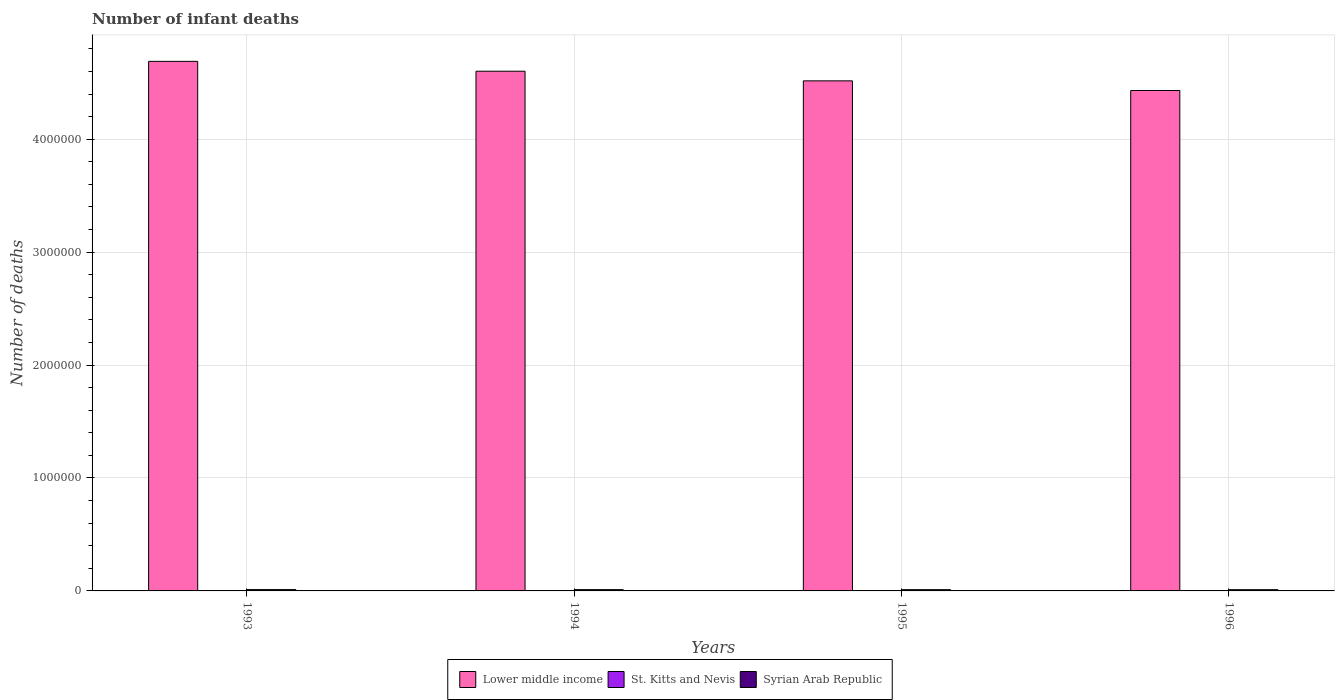How many different coloured bars are there?
Your response must be concise. 3. Are the number of bars per tick equal to the number of legend labels?
Provide a short and direct response. Yes. How many bars are there on the 4th tick from the left?
Provide a short and direct response. 3. What is the label of the 2nd group of bars from the left?
Give a very brief answer. 1994. What is the number of infant deaths in Lower middle income in 1994?
Offer a terse response. 4.60e+06. What is the total number of infant deaths in Syrian Arab Republic in the graph?
Keep it short and to the point. 4.48e+04. What is the difference between the number of infant deaths in St. Kitts and Nevis in 1993 and that in 1994?
Offer a very short reply. 0. What is the difference between the number of infant deaths in Syrian Arab Republic in 1993 and the number of infant deaths in St. Kitts and Nevis in 1995?
Give a very brief answer. 1.17e+04. What is the average number of infant deaths in Syrian Arab Republic per year?
Your answer should be compact. 1.12e+04. In the year 1995, what is the difference between the number of infant deaths in St. Kitts and Nevis and number of infant deaths in Syrian Arab Republic?
Your response must be concise. -1.09e+04. In how many years, is the number of infant deaths in Syrian Arab Republic greater than 200000?
Give a very brief answer. 0. What is the ratio of the number of infant deaths in Lower middle income in 1993 to that in 1996?
Ensure brevity in your answer.  1.06. Is the number of infant deaths in Syrian Arab Republic in 1994 less than that in 1996?
Your answer should be very brief. No. What is the difference between the highest and the second highest number of infant deaths in St. Kitts and Nevis?
Offer a very short reply. 0. What is the difference between the highest and the lowest number of infant deaths in Lower middle income?
Keep it short and to the point. 2.58e+05. What does the 2nd bar from the left in 1996 represents?
Provide a short and direct response. St. Kitts and Nevis. What does the 3rd bar from the right in 1995 represents?
Provide a succinct answer. Lower middle income. Is it the case that in every year, the sum of the number of infant deaths in Syrian Arab Republic and number of infant deaths in St. Kitts and Nevis is greater than the number of infant deaths in Lower middle income?
Offer a very short reply. No. What is the difference between two consecutive major ticks on the Y-axis?
Your response must be concise. 1.00e+06. Does the graph contain any zero values?
Provide a short and direct response. No. Does the graph contain grids?
Keep it short and to the point. Yes. Where does the legend appear in the graph?
Keep it short and to the point. Bottom center. How are the legend labels stacked?
Ensure brevity in your answer.  Horizontal. What is the title of the graph?
Give a very brief answer. Number of infant deaths. Does "Malta" appear as one of the legend labels in the graph?
Your response must be concise. No. What is the label or title of the Y-axis?
Keep it short and to the point. Number of deaths. What is the Number of deaths in Lower middle income in 1993?
Provide a succinct answer. 4.69e+06. What is the Number of deaths in St. Kitts and Nevis in 1993?
Your answer should be very brief. 18. What is the Number of deaths of Syrian Arab Republic in 1993?
Your answer should be compact. 1.17e+04. What is the Number of deaths in Lower middle income in 1994?
Offer a very short reply. 4.60e+06. What is the Number of deaths of St. Kitts and Nevis in 1994?
Offer a very short reply. 18. What is the Number of deaths of Syrian Arab Republic in 1994?
Keep it short and to the point. 1.13e+04. What is the Number of deaths of Lower middle income in 1995?
Give a very brief answer. 4.52e+06. What is the Number of deaths in St. Kitts and Nevis in 1995?
Provide a succinct answer. 17. What is the Number of deaths in Syrian Arab Republic in 1995?
Your answer should be very brief. 1.09e+04. What is the Number of deaths in Lower middle income in 1996?
Offer a very short reply. 4.43e+06. What is the Number of deaths of Syrian Arab Republic in 1996?
Provide a short and direct response. 1.09e+04. Across all years, what is the maximum Number of deaths of Lower middle income?
Give a very brief answer. 4.69e+06. Across all years, what is the maximum Number of deaths of St. Kitts and Nevis?
Make the answer very short. 18. Across all years, what is the maximum Number of deaths of Syrian Arab Republic?
Give a very brief answer. 1.17e+04. Across all years, what is the minimum Number of deaths in Lower middle income?
Your response must be concise. 4.43e+06. Across all years, what is the minimum Number of deaths in St. Kitts and Nevis?
Offer a very short reply. 17. Across all years, what is the minimum Number of deaths in Syrian Arab Republic?
Offer a terse response. 1.09e+04. What is the total Number of deaths of Lower middle income in the graph?
Offer a terse response. 1.82e+07. What is the total Number of deaths of Syrian Arab Republic in the graph?
Your response must be concise. 4.48e+04. What is the difference between the Number of deaths of Lower middle income in 1993 and that in 1994?
Provide a succinct answer. 8.73e+04. What is the difference between the Number of deaths of St. Kitts and Nevis in 1993 and that in 1994?
Your answer should be compact. 0. What is the difference between the Number of deaths of Syrian Arab Republic in 1993 and that in 1994?
Make the answer very short. 451. What is the difference between the Number of deaths of Lower middle income in 1993 and that in 1995?
Provide a short and direct response. 1.73e+05. What is the difference between the Number of deaths in St. Kitts and Nevis in 1993 and that in 1995?
Make the answer very short. 1. What is the difference between the Number of deaths in Syrian Arab Republic in 1993 and that in 1995?
Provide a succinct answer. 765. What is the difference between the Number of deaths of Lower middle income in 1993 and that in 1996?
Make the answer very short. 2.58e+05. What is the difference between the Number of deaths in Syrian Arab Republic in 1993 and that in 1996?
Give a very brief answer. 848. What is the difference between the Number of deaths of Lower middle income in 1994 and that in 1995?
Your response must be concise. 8.54e+04. What is the difference between the Number of deaths in St. Kitts and Nevis in 1994 and that in 1995?
Ensure brevity in your answer.  1. What is the difference between the Number of deaths of Syrian Arab Republic in 1994 and that in 1995?
Offer a terse response. 314. What is the difference between the Number of deaths in Lower middle income in 1994 and that in 1996?
Provide a succinct answer. 1.71e+05. What is the difference between the Number of deaths in St. Kitts and Nevis in 1994 and that in 1996?
Your answer should be very brief. 1. What is the difference between the Number of deaths in Syrian Arab Republic in 1994 and that in 1996?
Keep it short and to the point. 397. What is the difference between the Number of deaths of Lower middle income in 1995 and that in 1996?
Ensure brevity in your answer.  8.55e+04. What is the difference between the Number of deaths of St. Kitts and Nevis in 1995 and that in 1996?
Offer a terse response. 0. What is the difference between the Number of deaths in Lower middle income in 1993 and the Number of deaths in St. Kitts and Nevis in 1994?
Keep it short and to the point. 4.69e+06. What is the difference between the Number of deaths of Lower middle income in 1993 and the Number of deaths of Syrian Arab Republic in 1994?
Make the answer very short. 4.68e+06. What is the difference between the Number of deaths of St. Kitts and Nevis in 1993 and the Number of deaths of Syrian Arab Republic in 1994?
Provide a short and direct response. -1.12e+04. What is the difference between the Number of deaths in Lower middle income in 1993 and the Number of deaths in St. Kitts and Nevis in 1995?
Keep it short and to the point. 4.69e+06. What is the difference between the Number of deaths in Lower middle income in 1993 and the Number of deaths in Syrian Arab Republic in 1995?
Make the answer very short. 4.68e+06. What is the difference between the Number of deaths in St. Kitts and Nevis in 1993 and the Number of deaths in Syrian Arab Republic in 1995?
Your response must be concise. -1.09e+04. What is the difference between the Number of deaths of Lower middle income in 1993 and the Number of deaths of St. Kitts and Nevis in 1996?
Your answer should be very brief. 4.69e+06. What is the difference between the Number of deaths in Lower middle income in 1993 and the Number of deaths in Syrian Arab Republic in 1996?
Your answer should be very brief. 4.68e+06. What is the difference between the Number of deaths of St. Kitts and Nevis in 1993 and the Number of deaths of Syrian Arab Republic in 1996?
Keep it short and to the point. -1.08e+04. What is the difference between the Number of deaths of Lower middle income in 1994 and the Number of deaths of St. Kitts and Nevis in 1995?
Offer a very short reply. 4.60e+06. What is the difference between the Number of deaths in Lower middle income in 1994 and the Number of deaths in Syrian Arab Republic in 1995?
Your answer should be compact. 4.59e+06. What is the difference between the Number of deaths in St. Kitts and Nevis in 1994 and the Number of deaths in Syrian Arab Republic in 1995?
Keep it short and to the point. -1.09e+04. What is the difference between the Number of deaths of Lower middle income in 1994 and the Number of deaths of St. Kitts and Nevis in 1996?
Ensure brevity in your answer.  4.60e+06. What is the difference between the Number of deaths in Lower middle income in 1994 and the Number of deaths in Syrian Arab Republic in 1996?
Your response must be concise. 4.59e+06. What is the difference between the Number of deaths in St. Kitts and Nevis in 1994 and the Number of deaths in Syrian Arab Republic in 1996?
Your response must be concise. -1.08e+04. What is the difference between the Number of deaths of Lower middle income in 1995 and the Number of deaths of St. Kitts and Nevis in 1996?
Your answer should be compact. 4.52e+06. What is the difference between the Number of deaths of Lower middle income in 1995 and the Number of deaths of Syrian Arab Republic in 1996?
Ensure brevity in your answer.  4.51e+06. What is the difference between the Number of deaths of St. Kitts and Nevis in 1995 and the Number of deaths of Syrian Arab Republic in 1996?
Keep it short and to the point. -1.08e+04. What is the average Number of deaths in Lower middle income per year?
Keep it short and to the point. 4.56e+06. What is the average Number of deaths in Syrian Arab Republic per year?
Keep it short and to the point. 1.12e+04. In the year 1993, what is the difference between the Number of deaths of Lower middle income and Number of deaths of St. Kitts and Nevis?
Provide a succinct answer. 4.69e+06. In the year 1993, what is the difference between the Number of deaths of Lower middle income and Number of deaths of Syrian Arab Republic?
Your answer should be compact. 4.68e+06. In the year 1993, what is the difference between the Number of deaths of St. Kitts and Nevis and Number of deaths of Syrian Arab Republic?
Offer a terse response. -1.17e+04. In the year 1994, what is the difference between the Number of deaths of Lower middle income and Number of deaths of St. Kitts and Nevis?
Your response must be concise. 4.60e+06. In the year 1994, what is the difference between the Number of deaths in Lower middle income and Number of deaths in Syrian Arab Republic?
Keep it short and to the point. 4.59e+06. In the year 1994, what is the difference between the Number of deaths in St. Kitts and Nevis and Number of deaths in Syrian Arab Republic?
Offer a very short reply. -1.12e+04. In the year 1995, what is the difference between the Number of deaths of Lower middle income and Number of deaths of St. Kitts and Nevis?
Ensure brevity in your answer.  4.52e+06. In the year 1995, what is the difference between the Number of deaths of Lower middle income and Number of deaths of Syrian Arab Republic?
Offer a very short reply. 4.51e+06. In the year 1995, what is the difference between the Number of deaths of St. Kitts and Nevis and Number of deaths of Syrian Arab Republic?
Offer a very short reply. -1.09e+04. In the year 1996, what is the difference between the Number of deaths of Lower middle income and Number of deaths of St. Kitts and Nevis?
Make the answer very short. 4.43e+06. In the year 1996, what is the difference between the Number of deaths in Lower middle income and Number of deaths in Syrian Arab Republic?
Offer a terse response. 4.42e+06. In the year 1996, what is the difference between the Number of deaths of St. Kitts and Nevis and Number of deaths of Syrian Arab Republic?
Offer a very short reply. -1.08e+04. What is the ratio of the Number of deaths in Lower middle income in 1993 to that in 1994?
Make the answer very short. 1.02. What is the ratio of the Number of deaths in Syrian Arab Republic in 1993 to that in 1994?
Provide a short and direct response. 1.04. What is the ratio of the Number of deaths of Lower middle income in 1993 to that in 1995?
Offer a terse response. 1.04. What is the ratio of the Number of deaths of St. Kitts and Nevis in 1993 to that in 1995?
Your response must be concise. 1.06. What is the ratio of the Number of deaths in Syrian Arab Republic in 1993 to that in 1995?
Your answer should be compact. 1.07. What is the ratio of the Number of deaths of Lower middle income in 1993 to that in 1996?
Provide a short and direct response. 1.06. What is the ratio of the Number of deaths of St. Kitts and Nevis in 1993 to that in 1996?
Provide a short and direct response. 1.06. What is the ratio of the Number of deaths in Syrian Arab Republic in 1993 to that in 1996?
Your answer should be compact. 1.08. What is the ratio of the Number of deaths in Lower middle income in 1994 to that in 1995?
Your response must be concise. 1.02. What is the ratio of the Number of deaths of St. Kitts and Nevis in 1994 to that in 1995?
Your response must be concise. 1.06. What is the ratio of the Number of deaths in Syrian Arab Republic in 1994 to that in 1995?
Keep it short and to the point. 1.03. What is the ratio of the Number of deaths in Lower middle income in 1994 to that in 1996?
Your answer should be compact. 1.04. What is the ratio of the Number of deaths of St. Kitts and Nevis in 1994 to that in 1996?
Offer a terse response. 1.06. What is the ratio of the Number of deaths in Syrian Arab Republic in 1994 to that in 1996?
Offer a terse response. 1.04. What is the ratio of the Number of deaths in Lower middle income in 1995 to that in 1996?
Ensure brevity in your answer.  1.02. What is the ratio of the Number of deaths of Syrian Arab Republic in 1995 to that in 1996?
Offer a terse response. 1.01. What is the difference between the highest and the second highest Number of deaths of Lower middle income?
Your response must be concise. 8.73e+04. What is the difference between the highest and the second highest Number of deaths of Syrian Arab Republic?
Your answer should be compact. 451. What is the difference between the highest and the lowest Number of deaths of Lower middle income?
Keep it short and to the point. 2.58e+05. What is the difference between the highest and the lowest Number of deaths in Syrian Arab Republic?
Give a very brief answer. 848. 